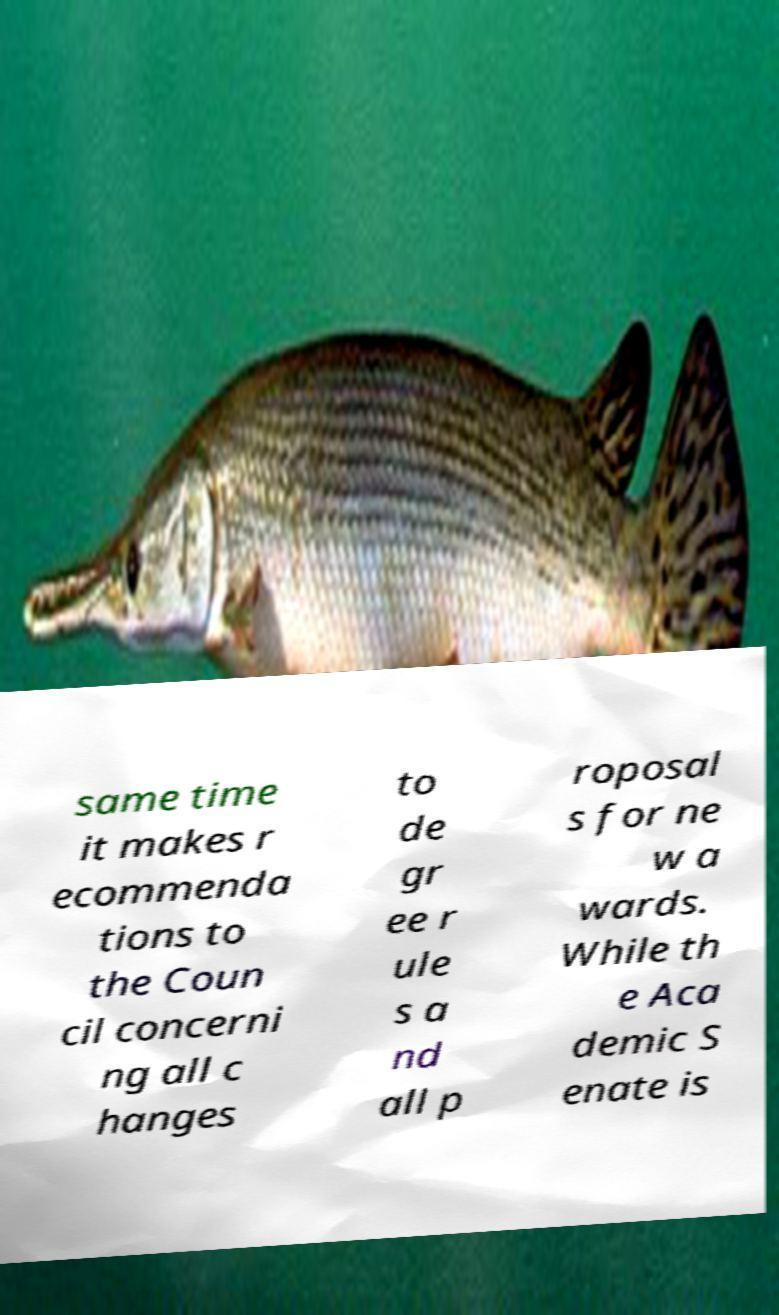Could you assist in decoding the text presented in this image and type it out clearly? same time it makes r ecommenda tions to the Coun cil concerni ng all c hanges to de gr ee r ule s a nd all p roposal s for ne w a wards. While th e Aca demic S enate is 